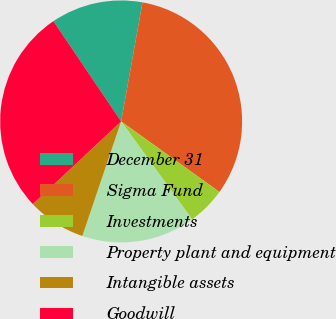Convert chart to OTSL. <chart><loc_0><loc_0><loc_500><loc_500><pie_chart><fcel>December 31<fcel>Sigma Fund<fcel>Investments<fcel>Property plant and equipment<fcel>Intangible assets<fcel>Goodwill<nl><fcel>12.28%<fcel>32.08%<fcel>5.12%<fcel>15.18%<fcel>7.82%<fcel>27.53%<nl></chart> 